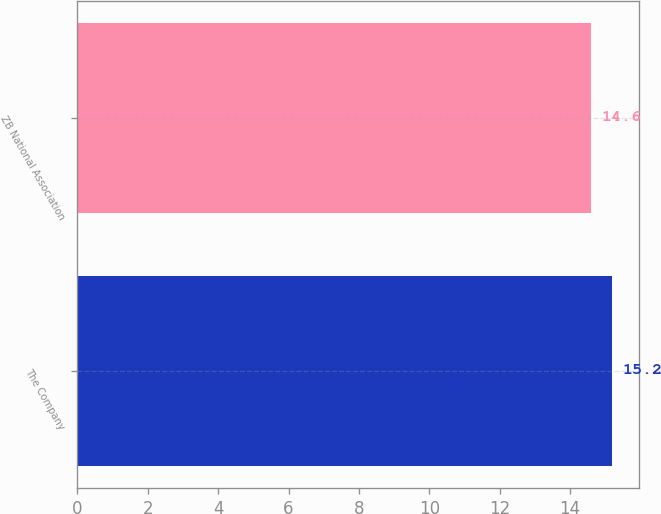<chart> <loc_0><loc_0><loc_500><loc_500><bar_chart><fcel>The Company<fcel>ZB National Association<nl><fcel>15.2<fcel>14.6<nl></chart> 